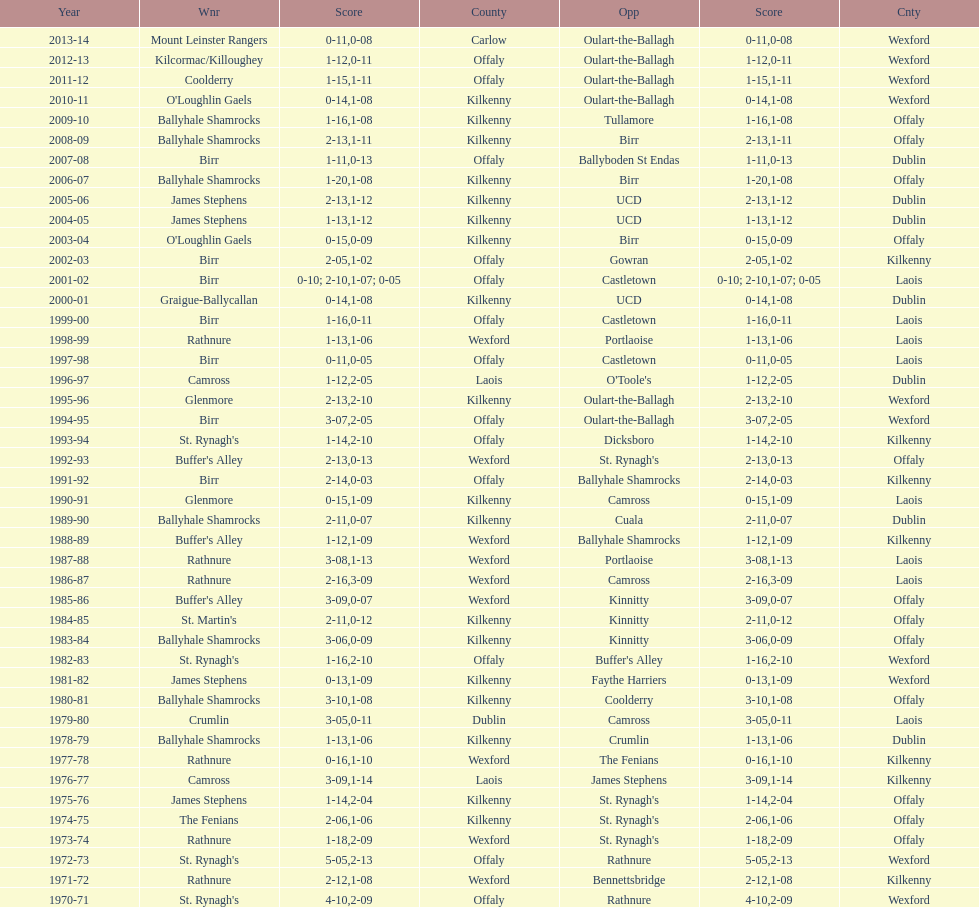Would you be able to parse every entry in this table? {'header': ['Year', 'Wnr', 'Score', 'County', 'Opp', 'Score', 'Cnty'], 'rows': [['2013-14', 'Mount Leinster Rangers', '0-11', 'Carlow', 'Oulart-the-Ballagh', '0-08', 'Wexford'], ['2012-13', 'Kilcormac/Killoughey', '1-12', 'Offaly', 'Oulart-the-Ballagh', '0-11', 'Wexford'], ['2011-12', 'Coolderry', '1-15', 'Offaly', 'Oulart-the-Ballagh', '1-11', 'Wexford'], ['2010-11', "O'Loughlin Gaels", '0-14', 'Kilkenny', 'Oulart-the-Ballagh', '1-08', 'Wexford'], ['2009-10', 'Ballyhale Shamrocks', '1-16', 'Kilkenny', 'Tullamore', '1-08', 'Offaly'], ['2008-09', 'Ballyhale Shamrocks', '2-13', 'Kilkenny', 'Birr', '1-11', 'Offaly'], ['2007-08', 'Birr', '1-11', 'Offaly', 'Ballyboden St Endas', '0-13', 'Dublin'], ['2006-07', 'Ballyhale Shamrocks', '1-20', 'Kilkenny', 'Birr', '1-08', 'Offaly'], ['2005-06', 'James Stephens', '2-13', 'Kilkenny', 'UCD', '1-12', 'Dublin'], ['2004-05', 'James Stephens', '1-13', 'Kilkenny', 'UCD', '1-12', 'Dublin'], ['2003-04', "O'Loughlin Gaels", '0-15', 'Kilkenny', 'Birr', '0-09', 'Offaly'], ['2002-03', 'Birr', '2-05', 'Offaly', 'Gowran', '1-02', 'Kilkenny'], ['2001-02', 'Birr', '0-10; 2-10', 'Offaly', 'Castletown', '1-07; 0-05', 'Laois'], ['2000-01', 'Graigue-Ballycallan', '0-14', 'Kilkenny', 'UCD', '1-08', 'Dublin'], ['1999-00', 'Birr', '1-16', 'Offaly', 'Castletown', '0-11', 'Laois'], ['1998-99', 'Rathnure', '1-13', 'Wexford', 'Portlaoise', '1-06', 'Laois'], ['1997-98', 'Birr', '0-11', 'Offaly', 'Castletown', '0-05', 'Laois'], ['1996-97', 'Camross', '1-12', 'Laois', "O'Toole's", '2-05', 'Dublin'], ['1995-96', 'Glenmore', '2-13', 'Kilkenny', 'Oulart-the-Ballagh', '2-10', 'Wexford'], ['1994-95', 'Birr', '3-07', 'Offaly', 'Oulart-the-Ballagh', '2-05', 'Wexford'], ['1993-94', "St. Rynagh's", '1-14', 'Offaly', 'Dicksboro', '2-10', 'Kilkenny'], ['1992-93', "Buffer's Alley", '2-13', 'Wexford', "St. Rynagh's", '0-13', 'Offaly'], ['1991-92', 'Birr', '2-14', 'Offaly', 'Ballyhale Shamrocks', '0-03', 'Kilkenny'], ['1990-91', 'Glenmore', '0-15', 'Kilkenny', 'Camross', '1-09', 'Laois'], ['1989-90', 'Ballyhale Shamrocks', '2-11', 'Kilkenny', 'Cuala', '0-07', 'Dublin'], ['1988-89', "Buffer's Alley", '1-12', 'Wexford', 'Ballyhale Shamrocks', '1-09', 'Kilkenny'], ['1987-88', 'Rathnure', '3-08', 'Wexford', 'Portlaoise', '1-13', 'Laois'], ['1986-87', 'Rathnure', '2-16', 'Wexford', 'Camross', '3-09', 'Laois'], ['1985-86', "Buffer's Alley", '3-09', 'Wexford', 'Kinnitty', '0-07', 'Offaly'], ['1984-85', "St. Martin's", '2-11', 'Kilkenny', 'Kinnitty', '0-12', 'Offaly'], ['1983-84', 'Ballyhale Shamrocks', '3-06', 'Kilkenny', 'Kinnitty', '0-09', 'Offaly'], ['1982-83', "St. Rynagh's", '1-16', 'Offaly', "Buffer's Alley", '2-10', 'Wexford'], ['1981-82', 'James Stephens', '0-13', 'Kilkenny', 'Faythe Harriers', '1-09', 'Wexford'], ['1980-81', 'Ballyhale Shamrocks', '3-10', 'Kilkenny', 'Coolderry', '1-08', 'Offaly'], ['1979-80', 'Crumlin', '3-05', 'Dublin', 'Camross', '0-11', 'Laois'], ['1978-79', 'Ballyhale Shamrocks', '1-13', 'Kilkenny', 'Crumlin', '1-06', 'Dublin'], ['1977-78', 'Rathnure', '0-16', 'Wexford', 'The Fenians', '1-10', 'Kilkenny'], ['1976-77', 'Camross', '3-09', 'Laois', 'James Stephens', '1-14', 'Kilkenny'], ['1975-76', 'James Stephens', '1-14', 'Kilkenny', "St. Rynagh's", '2-04', 'Offaly'], ['1974-75', 'The Fenians', '2-06', 'Kilkenny', "St. Rynagh's", '1-06', 'Offaly'], ['1973-74', 'Rathnure', '1-18', 'Wexford', "St. Rynagh's", '2-09', 'Offaly'], ['1972-73', "St. Rynagh's", '5-05', 'Offaly', 'Rathnure', '2-13', 'Wexford'], ['1971-72', 'Rathnure', '2-12', 'Wexford', 'Bennettsbridge', '1-08', 'Kilkenny'], ['1970-71', "St. Rynagh's", '4-10', 'Offaly', 'Rathnure', '2-09', 'Wexford']]} James stephens won in 1976-76. who won three years before that? St. Rynagh's. 